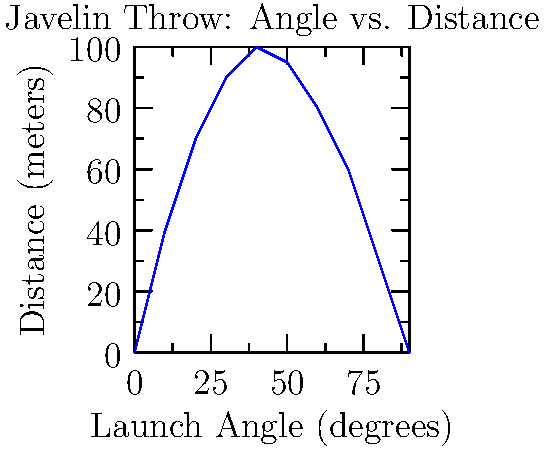As a javelin thrower aspiring to compete in the Olympics, you're studying the relationship between launch angle and throwing distance. The graph shows how the distance of a javelin throw varies with the launch angle. Based on this graph, what is the optimal launch angle (to the nearest 10 degrees) for achieving the maximum throwing distance? To find the optimal launch angle for the maximum throwing distance, we need to follow these steps:

1. Analyze the graph to identify the peak of the curve.
2. The peak represents the maximum distance achieved.
3. Find the corresponding angle on the x-axis for this peak.

Looking at the graph:

1. The curve starts at 0 meters for 0 degrees.
2. It rises steeply, reaching its highest point around 40 degrees.
3. After 40 degrees, the curve begins to descend.
4. At 90 degrees, the distance returns to 0 meters.

The peak of the curve appears to be at 40 degrees, corresponding to a distance of about 100 meters. This means that a launch angle of 40 degrees results in the maximum throwing distance.

To verify, we can see that:
- At 30 degrees, the distance is slightly less than 100 meters.
- At 50 degrees, the distance is also slightly less than 100 meters.

Therefore, 40 degrees is the optimal launch angle for achieving the maximum throwing distance.
Answer: 40 degrees 